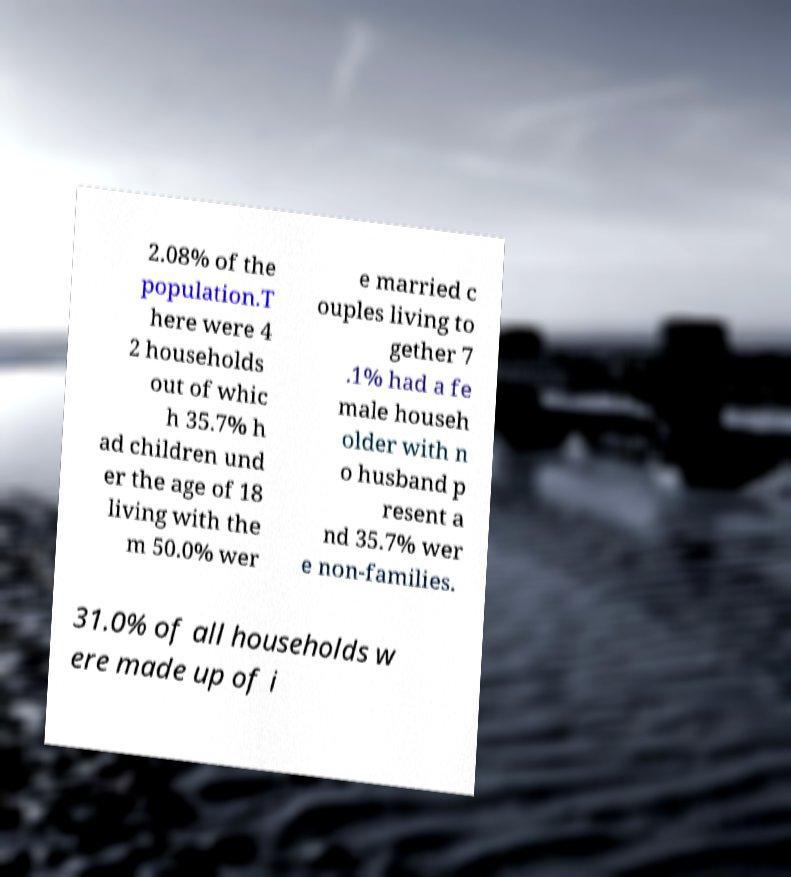Could you assist in decoding the text presented in this image and type it out clearly? 2.08% of the population.T here were 4 2 households out of whic h 35.7% h ad children und er the age of 18 living with the m 50.0% wer e married c ouples living to gether 7 .1% had a fe male househ older with n o husband p resent a nd 35.7% wer e non-families. 31.0% of all households w ere made up of i 